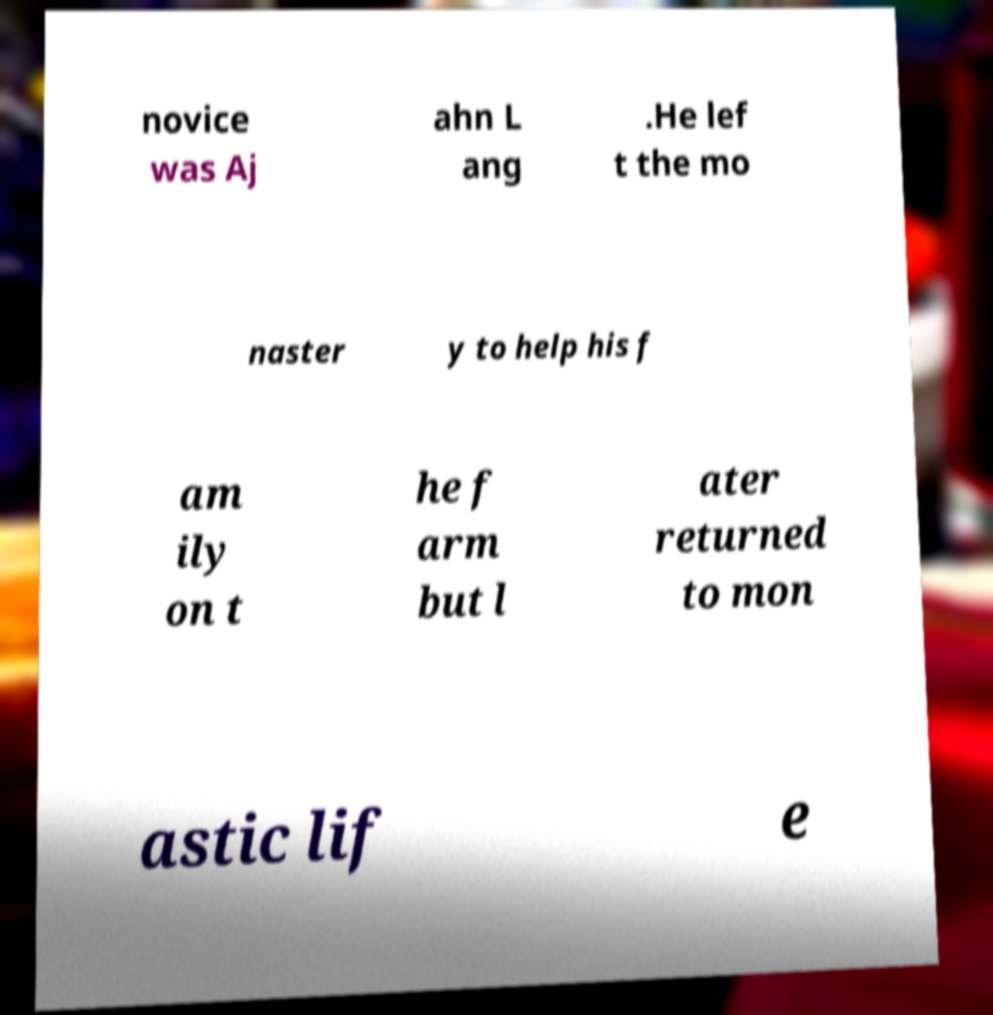Could you assist in decoding the text presented in this image and type it out clearly? novice was Aj ahn L ang .He lef t the mo naster y to help his f am ily on t he f arm but l ater returned to mon astic lif e 